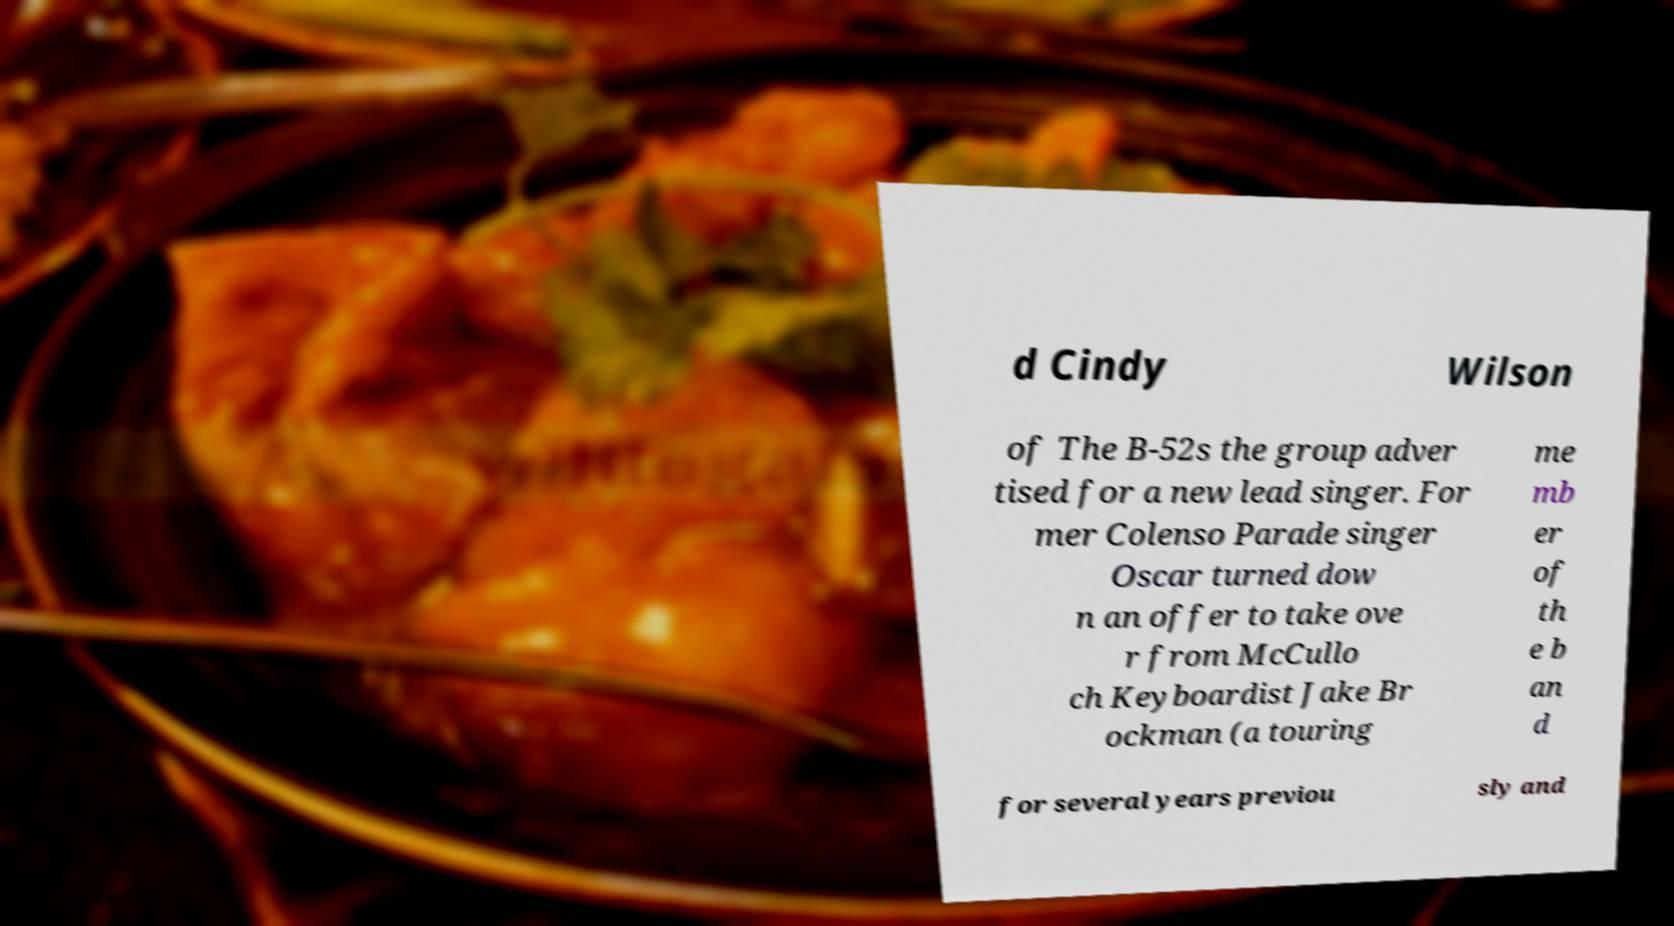Could you assist in decoding the text presented in this image and type it out clearly? d Cindy Wilson of The B-52s the group adver tised for a new lead singer. For mer Colenso Parade singer Oscar turned dow n an offer to take ove r from McCullo ch Keyboardist Jake Br ockman (a touring me mb er of th e b an d for several years previou sly and 